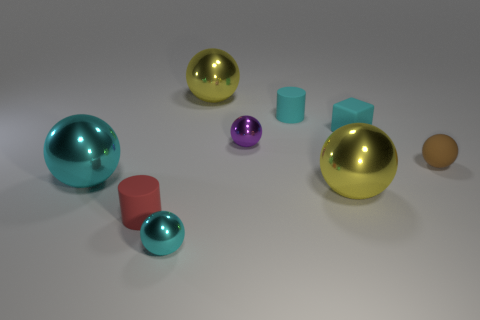How big is the rubber object that is in front of the cube and to the left of the tiny brown matte ball?
Offer a terse response. Small. There is a cylinder that is the same color as the small block; what is its material?
Ensure brevity in your answer.  Rubber. What number of large objects have the same color as the rubber cube?
Ensure brevity in your answer.  1. Is the number of matte balls that are in front of the small cyan metallic object the same as the number of small gray rubber objects?
Your answer should be compact. Yes. The matte block has what color?
Offer a very short reply. Cyan. What size is the cube that is the same material as the tiny brown ball?
Offer a very short reply. Small. The other tiny object that is made of the same material as the small purple object is what color?
Offer a terse response. Cyan. Is there a brown matte sphere of the same size as the red cylinder?
Offer a terse response. Yes. There is a small cyan object that is the same shape as the tiny brown matte thing; what is its material?
Offer a very short reply. Metal. There is a red matte object that is the same size as the purple ball; what shape is it?
Provide a succinct answer. Cylinder. 